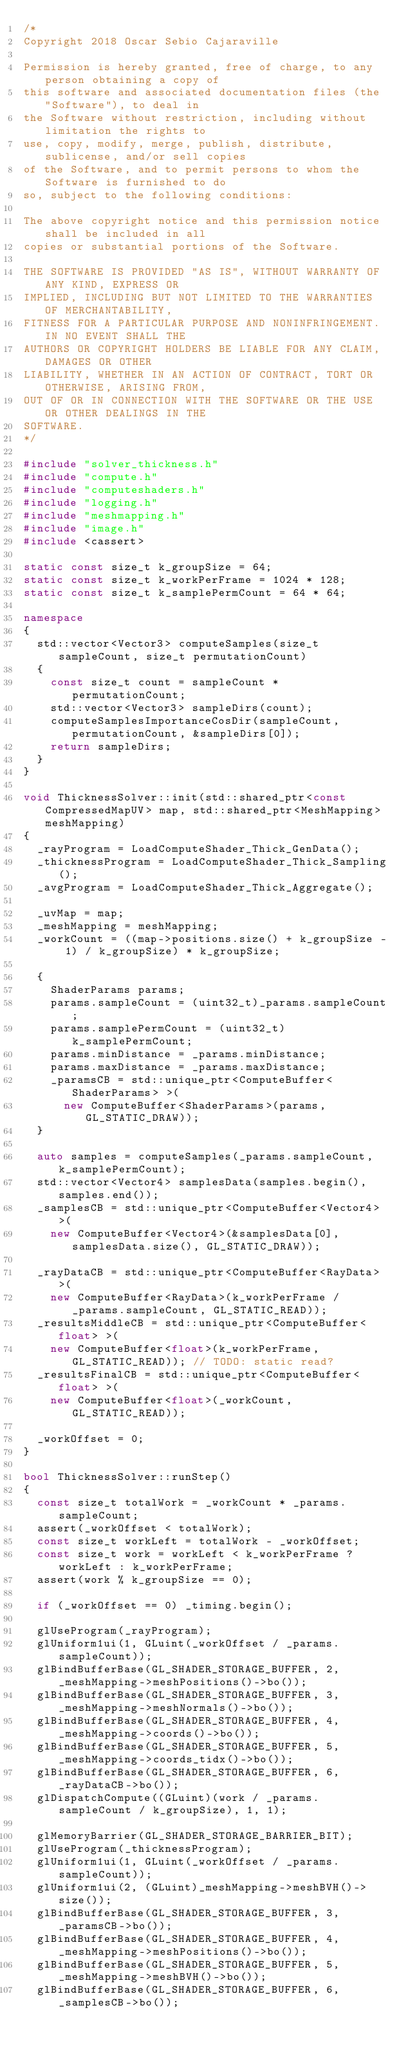Convert code to text. <code><loc_0><loc_0><loc_500><loc_500><_C++_>/*
Copyright 2018 Oscar Sebio Cajaraville

Permission is hereby granted, free of charge, to any person obtaining a copy of
this software and associated documentation files (the "Software"), to deal in
the Software without restriction, including without limitation the rights to
use, copy, modify, merge, publish, distribute, sublicense, and/or sell copies
of the Software, and to permit persons to whom the Software is furnished to do
so, subject to the following conditions:

The above copyright notice and this permission notice shall be included in all
copies or substantial portions of the Software.

THE SOFTWARE IS PROVIDED "AS IS", WITHOUT WARRANTY OF ANY KIND, EXPRESS OR
IMPLIED, INCLUDING BUT NOT LIMITED TO THE WARRANTIES OF MERCHANTABILITY,
FITNESS FOR A PARTICULAR PURPOSE AND NONINFRINGEMENT. IN NO EVENT SHALL THE
AUTHORS OR COPYRIGHT HOLDERS BE LIABLE FOR ANY CLAIM, DAMAGES OR OTHER
LIABILITY, WHETHER IN AN ACTION OF CONTRACT, TORT OR OTHERWISE, ARISING FROM,
OUT OF OR IN CONNECTION WITH THE SOFTWARE OR THE USE OR OTHER DEALINGS IN THE
SOFTWARE.
*/

#include "solver_thickness.h"
#include "compute.h"
#include "computeshaders.h"
#include "logging.h"
#include "meshmapping.h"
#include "image.h"
#include <cassert>

static const size_t k_groupSize = 64;
static const size_t k_workPerFrame = 1024 * 128;
static const size_t k_samplePermCount = 64 * 64;

namespace
{
	std::vector<Vector3> computeSamples(size_t sampleCount, size_t permutationCount)
	{
		const size_t count = sampleCount * permutationCount;
		std::vector<Vector3> sampleDirs(count);
		computeSamplesImportanceCosDir(sampleCount, permutationCount, &sampleDirs[0]);
		return sampleDirs;
	}
}

void ThicknessSolver::init(std::shared_ptr<const CompressedMapUV> map, std::shared_ptr<MeshMapping> meshMapping)
{
	_rayProgram = LoadComputeShader_Thick_GenData();
	_thicknessProgram = LoadComputeShader_Thick_Sampling();
	_avgProgram = LoadComputeShader_Thick_Aggregate();

	_uvMap = map;
	_meshMapping = meshMapping;
	_workCount = ((map->positions.size() + k_groupSize - 1) / k_groupSize) * k_groupSize;

	{
		ShaderParams params;
		params.sampleCount = (uint32_t)_params.sampleCount;
		params.samplePermCount = (uint32_t)k_samplePermCount;
		params.minDistance = _params.minDistance;
		params.maxDistance = _params.maxDistance;
		_paramsCB = std::unique_ptr<ComputeBuffer<ShaderParams> >(
			new ComputeBuffer<ShaderParams>(params, GL_STATIC_DRAW));
	}

	auto samples = computeSamples(_params.sampleCount, k_samplePermCount);
	std::vector<Vector4> samplesData(samples.begin(), samples.end());
	_samplesCB = std::unique_ptr<ComputeBuffer<Vector4> >(
		new ComputeBuffer<Vector4>(&samplesData[0], samplesData.size(), GL_STATIC_DRAW));

	_rayDataCB = std::unique_ptr<ComputeBuffer<RayData> >(
		new ComputeBuffer<RayData>(k_workPerFrame / _params.sampleCount, GL_STATIC_READ));
	_resultsMiddleCB = std::unique_ptr<ComputeBuffer<float> >(
		new ComputeBuffer<float>(k_workPerFrame, GL_STATIC_READ)); // TODO: static read?
	_resultsFinalCB = std::unique_ptr<ComputeBuffer<float> >(
		new ComputeBuffer<float>(_workCount, GL_STATIC_READ));

	_workOffset = 0;
}

bool ThicknessSolver::runStep()
{
	const size_t totalWork = _workCount * _params.sampleCount;
	assert(_workOffset < totalWork);
	const size_t workLeft = totalWork - _workOffset;
	const size_t work = workLeft < k_workPerFrame ? workLeft : k_workPerFrame;
	assert(work % k_groupSize == 0);

	if (_workOffset == 0) _timing.begin();

	glUseProgram(_rayProgram);
	glUniform1ui(1, GLuint(_workOffset / _params.sampleCount));
	glBindBufferBase(GL_SHADER_STORAGE_BUFFER, 2, _meshMapping->meshPositions()->bo());
	glBindBufferBase(GL_SHADER_STORAGE_BUFFER, 3, _meshMapping->meshNormals()->bo());
	glBindBufferBase(GL_SHADER_STORAGE_BUFFER, 4, _meshMapping->coords()->bo());
	glBindBufferBase(GL_SHADER_STORAGE_BUFFER, 5, _meshMapping->coords_tidx()->bo());
	glBindBufferBase(GL_SHADER_STORAGE_BUFFER, 6, _rayDataCB->bo());
	glDispatchCompute((GLuint)(work / _params.sampleCount / k_groupSize), 1, 1);

	glMemoryBarrier(GL_SHADER_STORAGE_BARRIER_BIT);
	glUseProgram(_thicknessProgram);
	glUniform1ui(1, GLuint(_workOffset / _params.sampleCount));
	glUniform1ui(2, (GLuint)_meshMapping->meshBVH()->size());
	glBindBufferBase(GL_SHADER_STORAGE_BUFFER, 3, _paramsCB->bo());
	glBindBufferBase(GL_SHADER_STORAGE_BUFFER, 4, _meshMapping->meshPositions()->bo());
	glBindBufferBase(GL_SHADER_STORAGE_BUFFER, 5, _meshMapping->meshBVH()->bo());
	glBindBufferBase(GL_SHADER_STORAGE_BUFFER, 6, _samplesCB->bo());</code> 